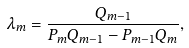Convert formula to latex. <formula><loc_0><loc_0><loc_500><loc_500>\lambda _ { m } = \frac { Q _ { m - 1 } } { P _ { m } Q _ { m - 1 } - P _ { m - 1 } Q _ { m } } ,</formula> 